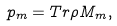Convert formula to latex. <formula><loc_0><loc_0><loc_500><loc_500>p _ { m } = T r \rho M _ { m } ,</formula> 